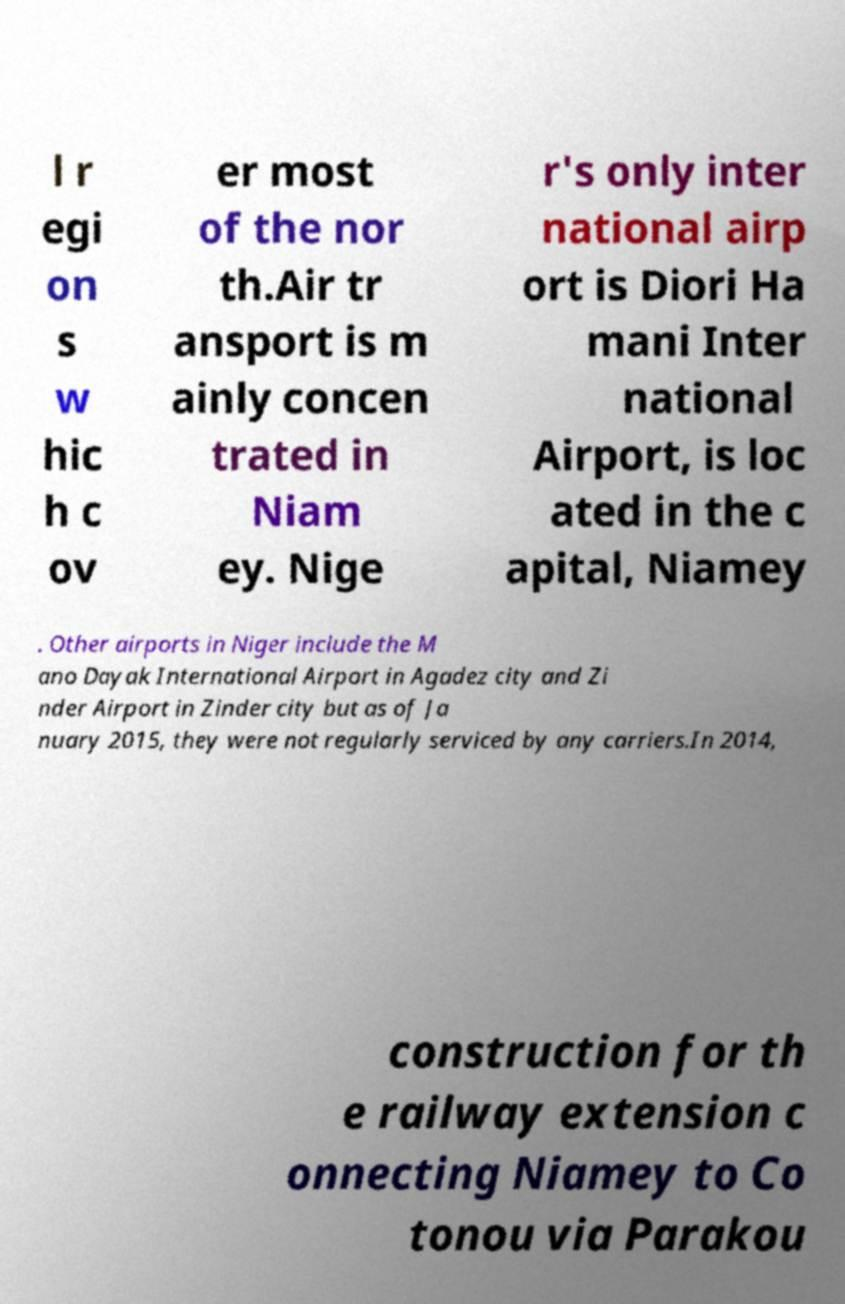Could you assist in decoding the text presented in this image and type it out clearly? l r egi on s w hic h c ov er most of the nor th.Air tr ansport is m ainly concen trated in Niam ey. Nige r's only inter national airp ort is Diori Ha mani Inter national Airport, is loc ated in the c apital, Niamey . Other airports in Niger include the M ano Dayak International Airport in Agadez city and Zi nder Airport in Zinder city but as of Ja nuary 2015, they were not regularly serviced by any carriers.In 2014, construction for th e railway extension c onnecting Niamey to Co tonou via Parakou 